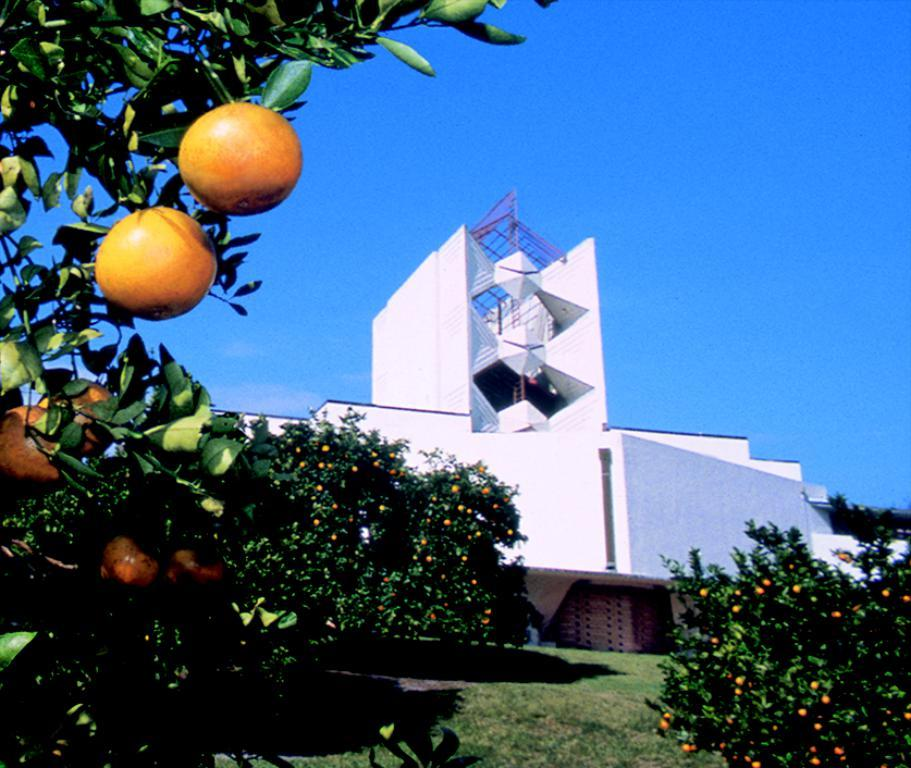What can be seen in the sky in the image? The sky is visible in the image. What type of structures are present in the image? There are buildings in the image. What kind of vegetation is present in the image? There are trees with fruits in the image. What is visible at the bottom of the image? The ground is visible in the image. How many degrees does the doctor have in the image? There is no doctor present in the image, so it is not possible to determine the number of degrees they might have. 